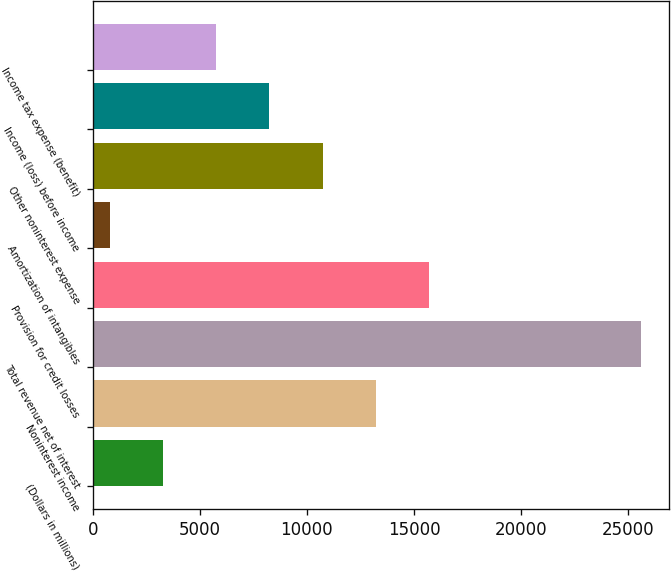Convert chart. <chart><loc_0><loc_0><loc_500><loc_500><bar_chart><fcel>(Dollars in millions)<fcel>Noninterest income<fcel>Total revenue net of interest<fcel>Provision for credit losses<fcel>Amortization of intangibles<fcel>Other noninterest expense<fcel>Income (loss) before income<fcel>Income tax expense (benefit)<nl><fcel>3293.8<fcel>13217<fcel>25621<fcel>15697.8<fcel>813<fcel>10736.2<fcel>8255.4<fcel>5774.6<nl></chart> 